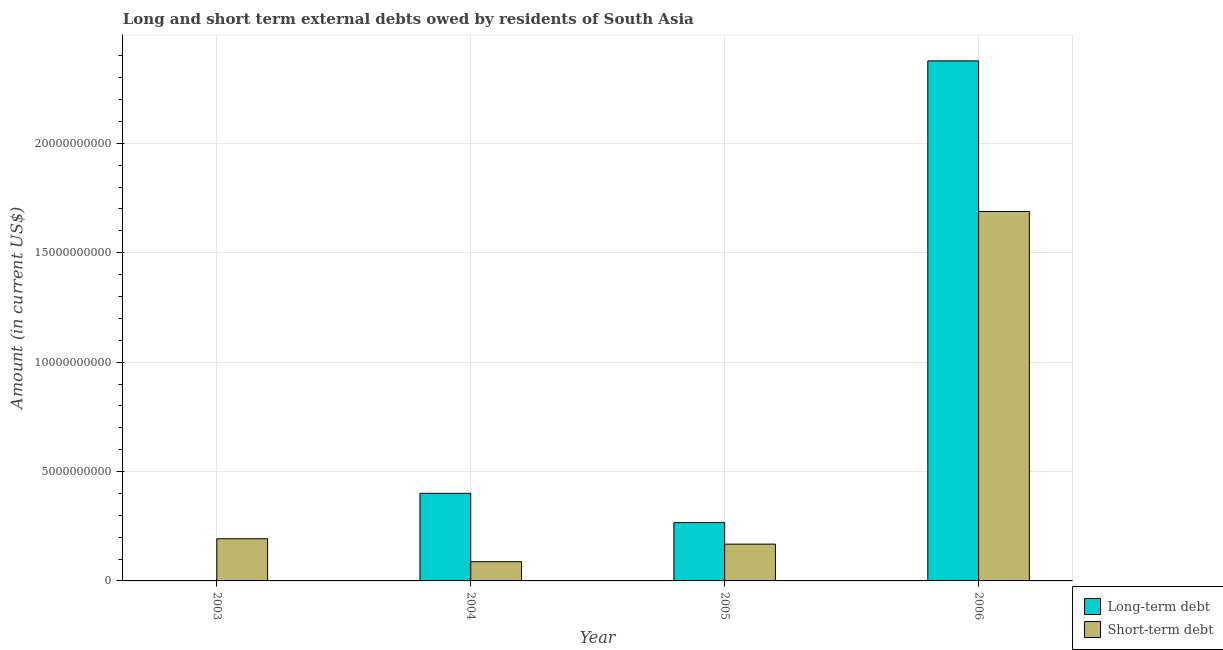How many different coloured bars are there?
Make the answer very short. 2. How many bars are there on the 1st tick from the right?
Your answer should be compact. 2. What is the label of the 2nd group of bars from the left?
Give a very brief answer. 2004. What is the long-term debts owed by residents in 2005?
Offer a terse response. 2.67e+09. Across all years, what is the maximum short-term debts owed by residents?
Your answer should be compact. 1.69e+1. In which year was the short-term debts owed by residents maximum?
Your answer should be compact. 2006. What is the total short-term debts owed by residents in the graph?
Offer a terse response. 2.14e+1. What is the difference between the long-term debts owed by residents in 2004 and that in 2006?
Make the answer very short. -1.98e+1. What is the difference between the long-term debts owed by residents in 2003 and the short-term debts owed by residents in 2004?
Make the answer very short. -4.00e+09. What is the average long-term debts owed by residents per year?
Your answer should be very brief. 7.61e+09. In the year 2006, what is the difference between the short-term debts owed by residents and long-term debts owed by residents?
Your answer should be compact. 0. What is the ratio of the long-term debts owed by residents in 2004 to that in 2005?
Make the answer very short. 1.5. What is the difference between the highest and the second highest long-term debts owed by residents?
Your answer should be very brief. 1.98e+1. What is the difference between the highest and the lowest short-term debts owed by residents?
Your answer should be compact. 1.60e+1. Is the sum of the long-term debts owed by residents in 2004 and 2005 greater than the maximum short-term debts owed by residents across all years?
Make the answer very short. No. Are all the bars in the graph horizontal?
Your response must be concise. No. Does the graph contain any zero values?
Make the answer very short. Yes. What is the title of the graph?
Provide a short and direct response. Long and short term external debts owed by residents of South Asia. Does "Death rate" appear as one of the legend labels in the graph?
Offer a very short reply. No. What is the Amount (in current US$) in Short-term debt in 2003?
Keep it short and to the point. 1.93e+09. What is the Amount (in current US$) in Long-term debt in 2004?
Ensure brevity in your answer.  4.00e+09. What is the Amount (in current US$) in Short-term debt in 2004?
Keep it short and to the point. 8.80e+08. What is the Amount (in current US$) in Long-term debt in 2005?
Provide a short and direct response. 2.67e+09. What is the Amount (in current US$) in Short-term debt in 2005?
Keep it short and to the point. 1.68e+09. What is the Amount (in current US$) of Long-term debt in 2006?
Your response must be concise. 2.38e+1. What is the Amount (in current US$) in Short-term debt in 2006?
Ensure brevity in your answer.  1.69e+1. Across all years, what is the maximum Amount (in current US$) in Long-term debt?
Provide a succinct answer. 2.38e+1. Across all years, what is the maximum Amount (in current US$) in Short-term debt?
Offer a terse response. 1.69e+1. Across all years, what is the minimum Amount (in current US$) of Short-term debt?
Ensure brevity in your answer.  8.80e+08. What is the total Amount (in current US$) in Long-term debt in the graph?
Your answer should be compact. 3.04e+1. What is the total Amount (in current US$) in Short-term debt in the graph?
Your answer should be very brief. 2.14e+1. What is the difference between the Amount (in current US$) of Short-term debt in 2003 and that in 2004?
Keep it short and to the point. 1.05e+09. What is the difference between the Amount (in current US$) in Short-term debt in 2003 and that in 2005?
Make the answer very short. 2.47e+08. What is the difference between the Amount (in current US$) of Short-term debt in 2003 and that in 2006?
Keep it short and to the point. -1.50e+1. What is the difference between the Amount (in current US$) in Long-term debt in 2004 and that in 2005?
Your response must be concise. 1.34e+09. What is the difference between the Amount (in current US$) of Short-term debt in 2004 and that in 2005?
Provide a short and direct response. -8.02e+08. What is the difference between the Amount (in current US$) of Long-term debt in 2004 and that in 2006?
Keep it short and to the point. -1.98e+1. What is the difference between the Amount (in current US$) of Short-term debt in 2004 and that in 2006?
Your response must be concise. -1.60e+1. What is the difference between the Amount (in current US$) in Long-term debt in 2005 and that in 2006?
Your answer should be very brief. -2.11e+1. What is the difference between the Amount (in current US$) of Short-term debt in 2005 and that in 2006?
Ensure brevity in your answer.  -1.52e+1. What is the difference between the Amount (in current US$) of Long-term debt in 2004 and the Amount (in current US$) of Short-term debt in 2005?
Give a very brief answer. 2.32e+09. What is the difference between the Amount (in current US$) of Long-term debt in 2004 and the Amount (in current US$) of Short-term debt in 2006?
Keep it short and to the point. -1.29e+1. What is the difference between the Amount (in current US$) of Long-term debt in 2005 and the Amount (in current US$) of Short-term debt in 2006?
Your answer should be compact. -1.42e+1. What is the average Amount (in current US$) of Long-term debt per year?
Your answer should be very brief. 7.61e+09. What is the average Amount (in current US$) in Short-term debt per year?
Provide a short and direct response. 5.34e+09. In the year 2004, what is the difference between the Amount (in current US$) in Long-term debt and Amount (in current US$) in Short-term debt?
Provide a short and direct response. 3.12e+09. In the year 2005, what is the difference between the Amount (in current US$) in Long-term debt and Amount (in current US$) in Short-term debt?
Provide a short and direct response. 9.86e+08. In the year 2006, what is the difference between the Amount (in current US$) of Long-term debt and Amount (in current US$) of Short-term debt?
Your answer should be compact. 6.88e+09. What is the ratio of the Amount (in current US$) of Short-term debt in 2003 to that in 2004?
Offer a terse response. 2.19. What is the ratio of the Amount (in current US$) in Short-term debt in 2003 to that in 2005?
Your response must be concise. 1.15. What is the ratio of the Amount (in current US$) in Short-term debt in 2003 to that in 2006?
Give a very brief answer. 0.11. What is the ratio of the Amount (in current US$) of Long-term debt in 2004 to that in 2005?
Offer a very short reply. 1.5. What is the ratio of the Amount (in current US$) of Short-term debt in 2004 to that in 2005?
Your answer should be very brief. 0.52. What is the ratio of the Amount (in current US$) of Long-term debt in 2004 to that in 2006?
Give a very brief answer. 0.17. What is the ratio of the Amount (in current US$) in Short-term debt in 2004 to that in 2006?
Make the answer very short. 0.05. What is the ratio of the Amount (in current US$) in Long-term debt in 2005 to that in 2006?
Your answer should be very brief. 0.11. What is the ratio of the Amount (in current US$) in Short-term debt in 2005 to that in 2006?
Provide a succinct answer. 0.1. What is the difference between the highest and the second highest Amount (in current US$) of Long-term debt?
Your response must be concise. 1.98e+1. What is the difference between the highest and the second highest Amount (in current US$) in Short-term debt?
Offer a terse response. 1.50e+1. What is the difference between the highest and the lowest Amount (in current US$) in Long-term debt?
Make the answer very short. 2.38e+1. What is the difference between the highest and the lowest Amount (in current US$) in Short-term debt?
Offer a very short reply. 1.60e+1. 